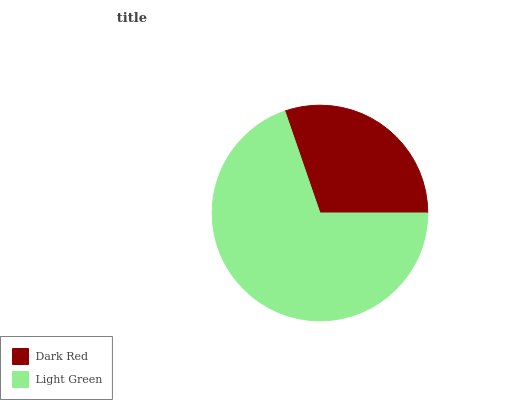Is Dark Red the minimum?
Answer yes or no. Yes. Is Light Green the maximum?
Answer yes or no. Yes. Is Light Green the minimum?
Answer yes or no. No. Is Light Green greater than Dark Red?
Answer yes or no. Yes. Is Dark Red less than Light Green?
Answer yes or no. Yes. Is Dark Red greater than Light Green?
Answer yes or no. No. Is Light Green less than Dark Red?
Answer yes or no. No. Is Light Green the high median?
Answer yes or no. Yes. Is Dark Red the low median?
Answer yes or no. Yes. Is Dark Red the high median?
Answer yes or no. No. Is Light Green the low median?
Answer yes or no. No. 